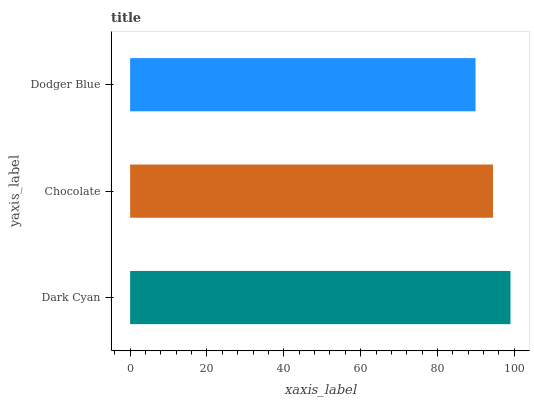Is Dodger Blue the minimum?
Answer yes or no. Yes. Is Dark Cyan the maximum?
Answer yes or no. Yes. Is Chocolate the minimum?
Answer yes or no. No. Is Chocolate the maximum?
Answer yes or no. No. Is Dark Cyan greater than Chocolate?
Answer yes or no. Yes. Is Chocolate less than Dark Cyan?
Answer yes or no. Yes. Is Chocolate greater than Dark Cyan?
Answer yes or no. No. Is Dark Cyan less than Chocolate?
Answer yes or no. No. Is Chocolate the high median?
Answer yes or no. Yes. Is Chocolate the low median?
Answer yes or no. Yes. Is Dark Cyan the high median?
Answer yes or no. No. Is Dark Cyan the low median?
Answer yes or no. No. 